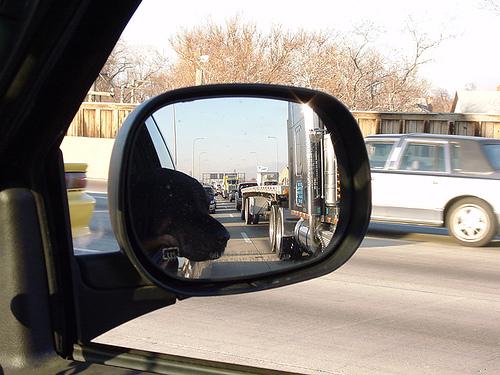What animal appears in the mirror?
Keep it brief. Dog. Is this a busy street?
Keep it brief. Yes. Is the dog looking at his image?
Quick response, please. No. 